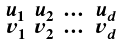<formula> <loc_0><loc_0><loc_500><loc_500>\begin{smallmatrix} u _ { 1 } & u _ { 2 } & \dots & u _ { d } \\ v _ { 1 } & v _ { 2 } & \dots & v _ { d } \end{smallmatrix}</formula> 